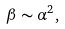<formula> <loc_0><loc_0><loc_500><loc_500>\beta \sim \alpha ^ { 2 } ,</formula> 